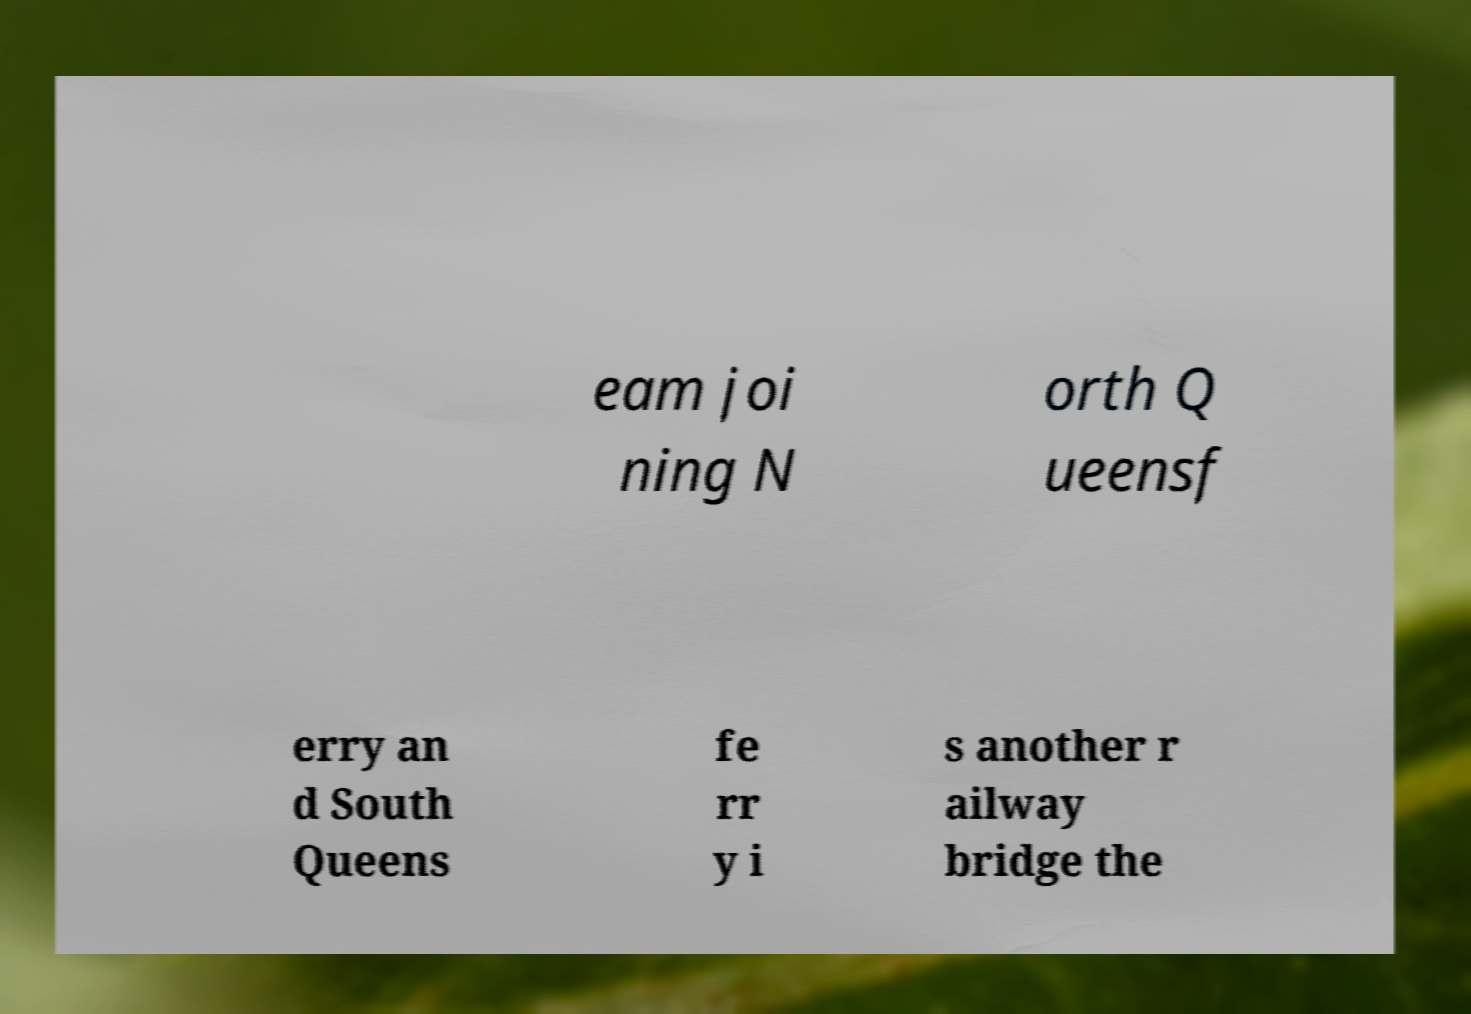Could you assist in decoding the text presented in this image and type it out clearly? eam joi ning N orth Q ueensf erry an d South Queens fe rr y i s another r ailway bridge the 